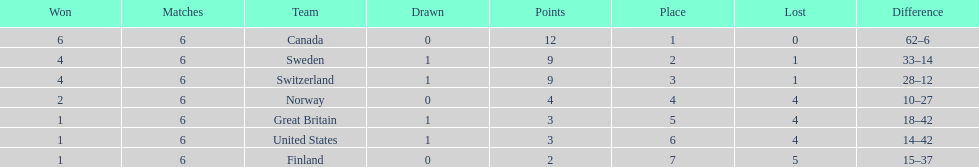Which country performed better during the 1951 world ice hockey championships, switzerland or great britain? Switzerland. 